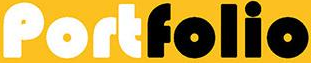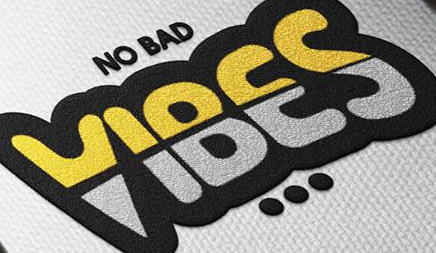What words can you see in these images in sequence, separated by a semicolon? Portfolio; VIBES 